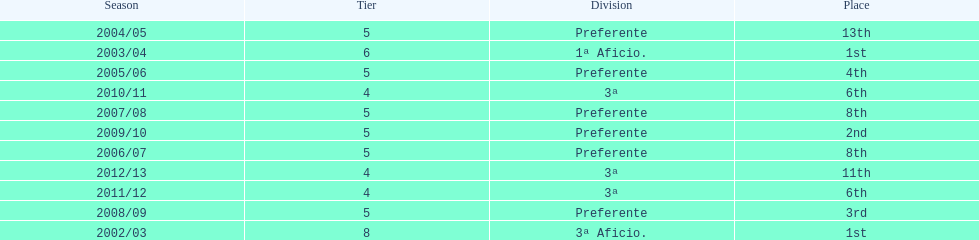How many years has internacional de madrid cf been active in the 3rd division? 3. 